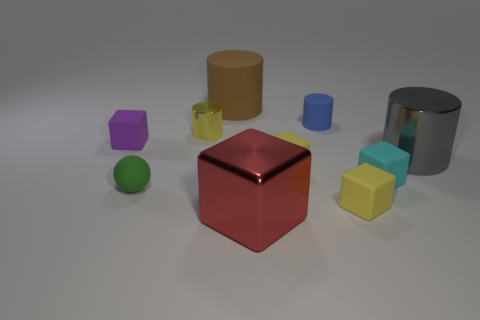Is there any other thing that has the same color as the small shiny thing?
Your response must be concise. Yes. How many cylinders are big gray metallic objects or big matte objects?
Offer a terse response. 2. What number of metal objects are both to the right of the red metallic block and in front of the small ball?
Ensure brevity in your answer.  0. Is the number of tiny rubber blocks that are behind the green thing the same as the number of tiny matte spheres that are behind the brown matte thing?
Keep it short and to the point. No. Do the matte thing that is in front of the green sphere and the gray thing have the same shape?
Ensure brevity in your answer.  No. What shape is the tiny green matte thing in front of the cylinder that is on the left side of the large cylinder that is behind the yellow shiny cylinder?
Make the answer very short. Sphere. The large thing that is both behind the small cyan rubber cube and left of the cyan rubber object is made of what material?
Make the answer very short. Rubber. Is the number of large metallic cylinders less than the number of metal cylinders?
Make the answer very short. Yes. There is a cyan rubber object; does it have the same shape as the small matte object behind the small shiny object?
Keep it short and to the point. No. There is a shiny cube on the right side of the green matte ball; is its size the same as the brown rubber thing?
Offer a terse response. Yes. 